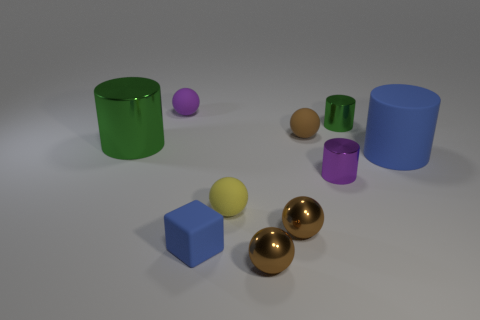There is a purple object that is in front of the purple rubber object; is it the same shape as the small green metallic thing?
Make the answer very short. Yes. How many other things are there of the same color as the big shiny object?
Keep it short and to the point. 1. Is the color of the cube the same as the big object that is on the right side of the yellow matte object?
Your answer should be compact. Yes. What is the color of the large matte thing that is the same shape as the tiny green object?
Provide a succinct answer. Blue. How many other green objects have the same shape as the big green object?
Keep it short and to the point. 1. What is the material of the other object that is the same color as the large shiny object?
Offer a terse response. Metal. The metallic thing that is the same color as the large metal cylinder is what size?
Give a very brief answer. Small. There is a purple shiny object that is in front of the big green metal cylinder; is its size the same as the yellow sphere on the left side of the blue cylinder?
Make the answer very short. Yes. There is a purple thing that is to the right of the matte block; how big is it?
Make the answer very short. Small. Is there a rubber ball that has the same color as the small matte block?
Provide a short and direct response. No. 